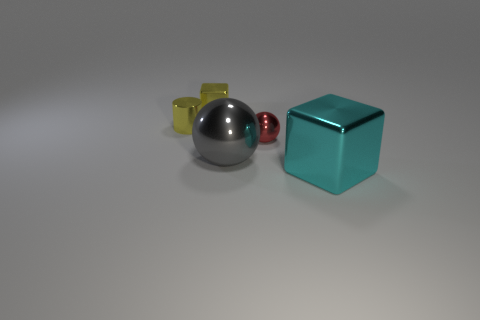Subtract all red spheres. How many spheres are left? 1 Subtract 1 spheres. How many spheres are left? 1 Subtract all blocks. How many objects are left? 3 Subtract all red cylinders. How many green balls are left? 0 Add 5 small things. How many objects exist? 10 Subtract 0 brown blocks. How many objects are left? 5 Subtract all cyan cubes. Subtract all purple balls. How many cubes are left? 1 Subtract all metallic cubes. Subtract all yellow cubes. How many objects are left? 2 Add 5 small yellow metal cylinders. How many small yellow metal cylinders are left? 6 Add 4 gray shiny objects. How many gray shiny objects exist? 5 